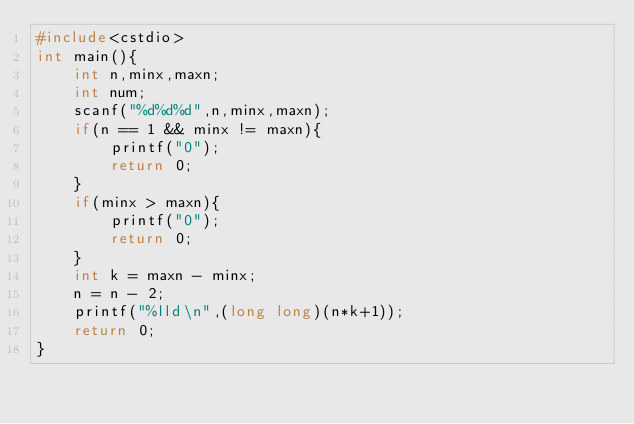Convert code to text. <code><loc_0><loc_0><loc_500><loc_500><_C++_>#include<cstdio>
int main(){
    int n,minx,maxn;
    int num;
    scanf("%d%d%d",n,minx,maxn);
    if(n == 1 && minx != maxn){
        printf("0");
        return 0;
    }
    if(minx > maxn){
        printf("0");
        return 0;
    }
    int k = maxn - minx;
    n = n - 2;
    printf("%lld\n",(long long)(n*k+1));
    return 0;
}</code> 